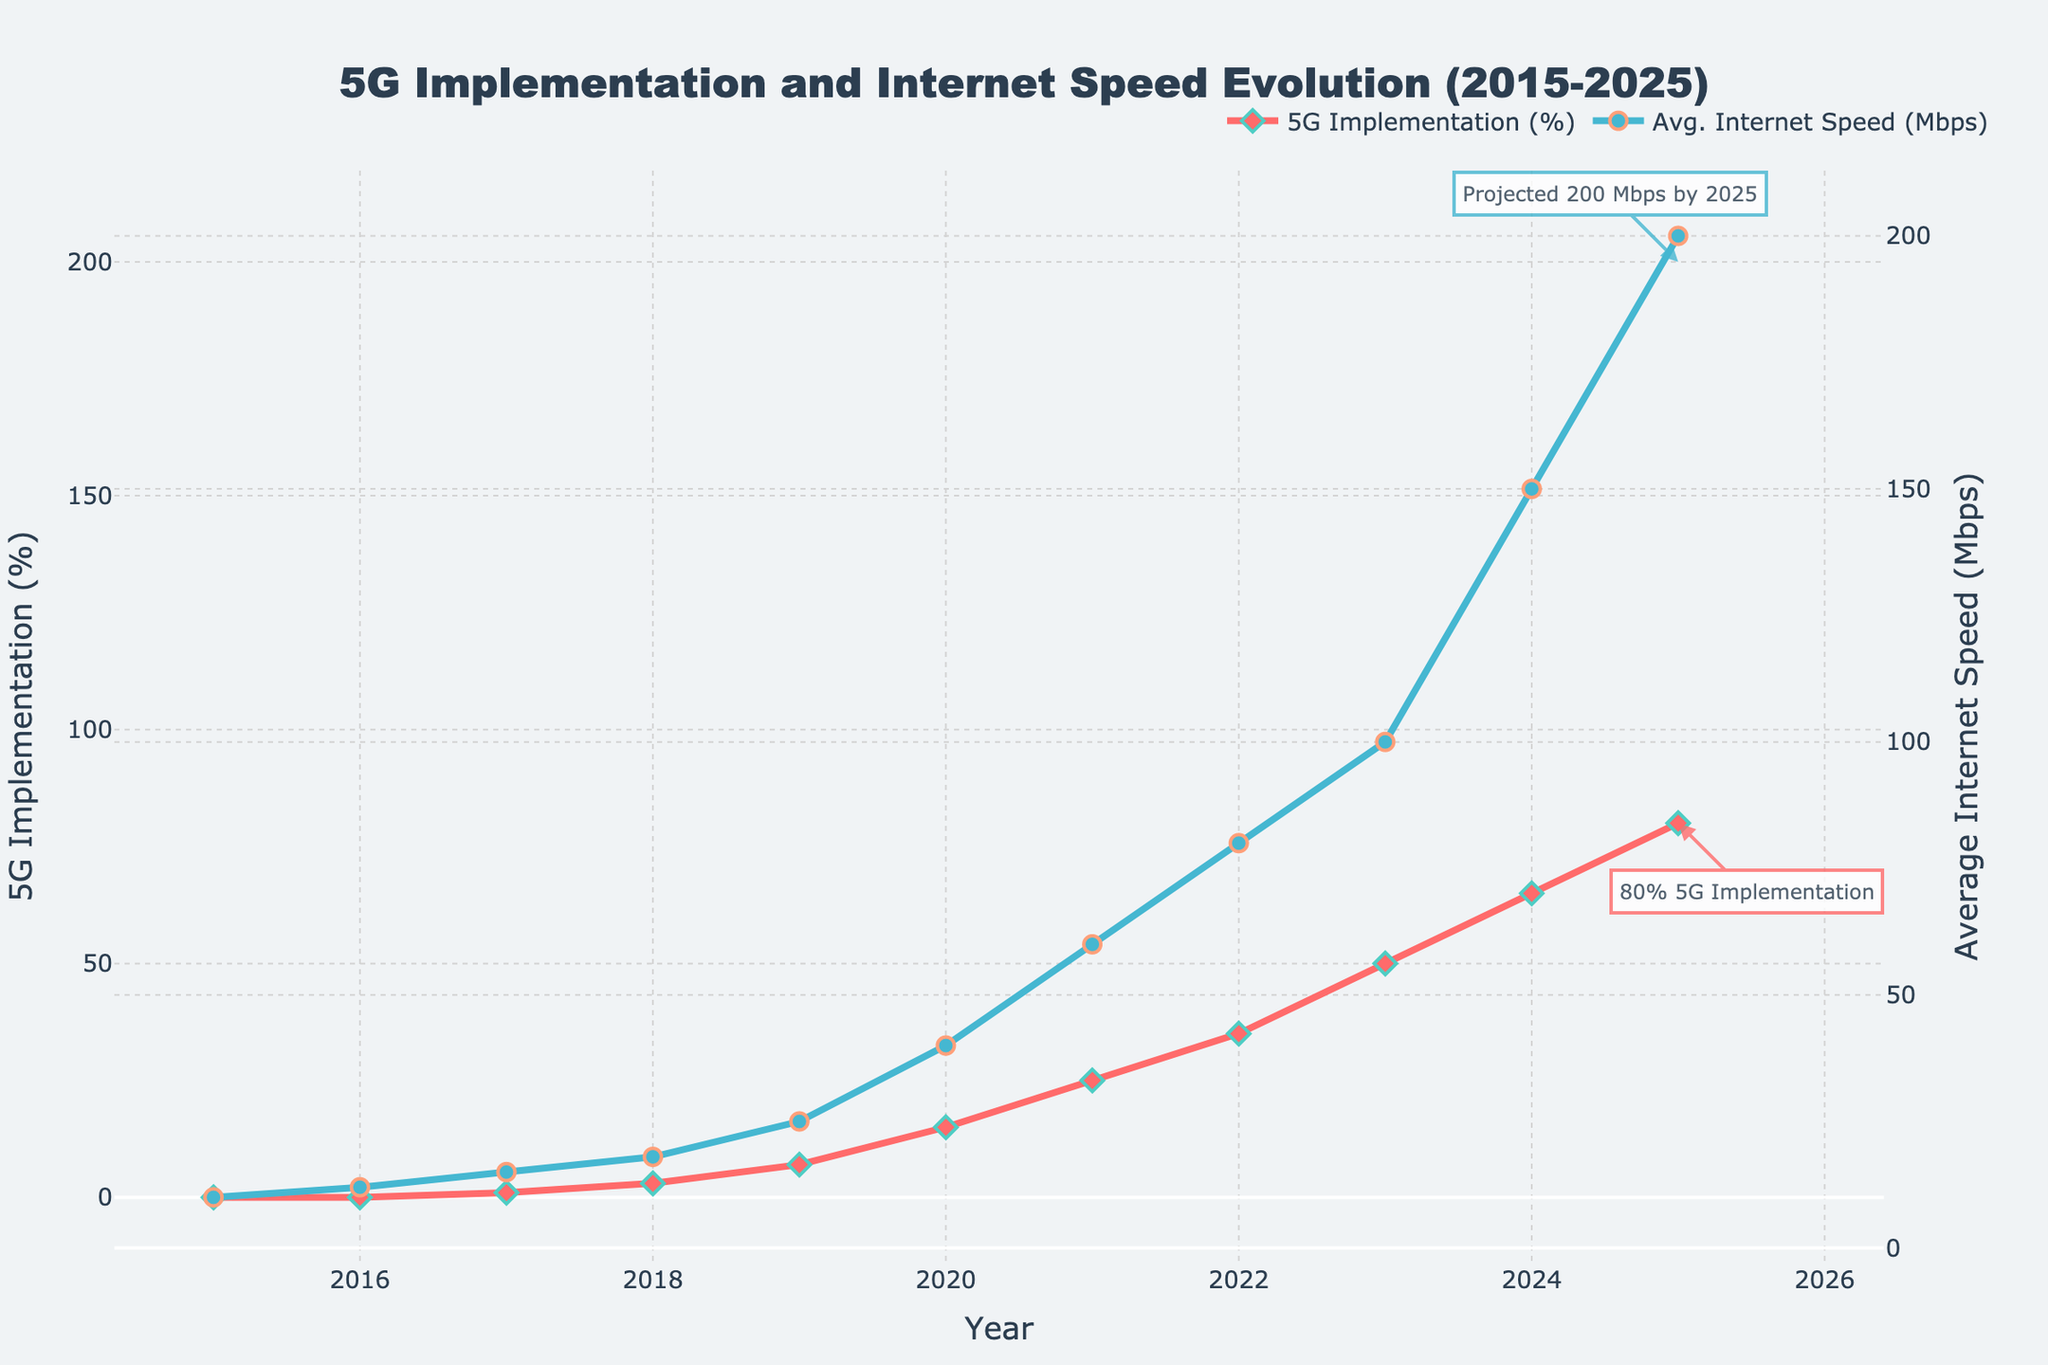What's the title of the figure? The title is prominently displayed at the top of the figure, making it easy to identify.
Answer: 5G Implementation and Internet Speed Evolution (2015-2025) In what year does 5G implementation first appear in the data? Locate the first non-zero value on the y-axis corresponding to 5G Implementation (%). Notice that 2017 is the first year with a value of 1%.
Answer: 2017 By how much did the average internet speed (in Mbps) increase from 2019 to 2020? Find the values for 2019 and 2020 on the 'Avg. Internet Speed (Mbps)' axis: 25 Mbps in 2019 and 40 Mbps in 2020. Subtract the 2019 value from the 2020 value: 40 - 25 = 15 Mbps.
Answer: 15 Mbps What is the average of the 5G implementation percentage values from 2019 to 2021 inclusive? Values: 7% (2019), 15% (2020), 25% (2021). \((7 + 15 + 25) / 3 = 47 / 3 \approx 15.67\)%
Answer: 15.67% Which year exhibited the highest increase in average internet speed compared to the previous year? List the speed differences year-over-year: 2016-2015 = 2, 2017-2016 = 3, 2018-2017 = 3, 2019-2018 = 7, 2020-2019 = 15, 2021-2020 = 20, 2022-2021 = 20, 2023-2022 = 20, 2024-2023 = 50, 2025-2024 = 50. The highest increase is 50 Mbps both from 2023-2024 and 2024-2025.
Answer: 2024-2025 What is the difference in 5G implementation percentage between 2025 and 2020? Values: 80% (2025), 15% (2020). Subtract: 80% - 15% = 65%.
Answer: 65% How did the average internet speed change from 2022 to 2023? Values: 80 Mbps (2022), 100 Mbps (2023). Subtract: 100 - 80 = 20 Mbps.
Answer: Increased by 20 Mbps Is the implementation percentage of 5G higher in 2023 or the average internet speed in 2018? Compare the values for 2023 and 2018: 5G Implementation % in 2023 is 50%, Avg Internet Speed in 2018 is 18 Mbps. 50 > 18.
Answer: 2023 In what year does the projected average internet speed reach 200 Mbps? Locate the annotation on the graph. It points to the year 2025 with a speed of 200 Mbps.
Answer: 2025 What two annotations are highlighted in the figure for the year 2025, and what do they indicate? Review the annotations: One indicates 'Projected 200 Mbps by 2025' on Avg. Internet Speed, and the other '80% 5G Implementation' on 5G Implementation %.
Answer: Projected 200 Mbps by 2025, 80% 5G Implementation 